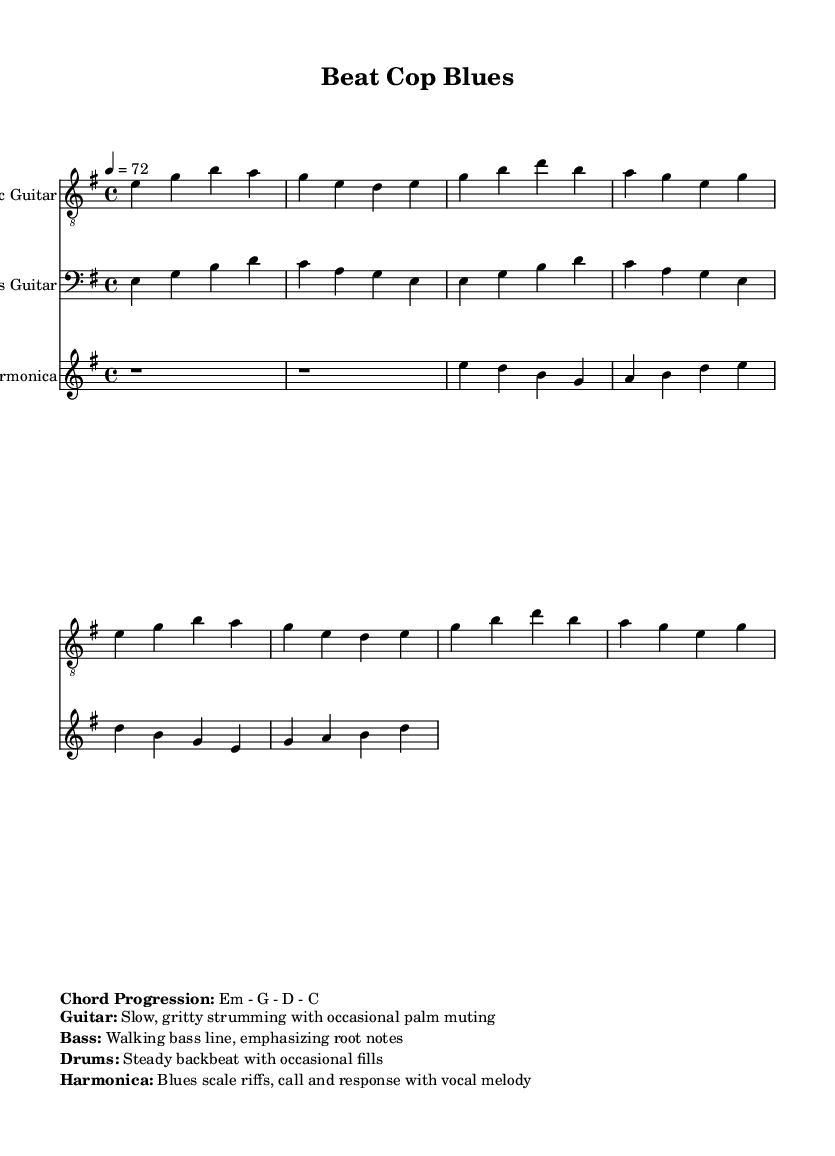What is the time signature of the music? The time signature is indicated at the beginning of the piece as a fraction, showing the number of beats per measure. In this case, it is shown as 4/4.
Answer: 4/4 What key is this piece written in? The key signature is found at the beginning of the score. It shows the piece is in E minor, as indicated by the key signature symbol.
Answer: E minor What is the tempo marking specified in the music? The tempo marking indicates the speed of the piece, typically noted in beats per minute. Here, it is written as "4 = 72."
Answer: 72 How many measures are repeated in the electric guitar part? The electric guitar part contains a section that uses the "repeat" directive, suggesting it should be played two times.
Answer: 2 Which instrument plays the walking bass line? The bass guitar section, designated in the score, typically performs a walking bass line which emphasizes the root notes. This information is explicitly described in the musical directions.
Answer: Bass Guitar What style of strumming is indicated for the electric guitar? The instructions state the guitar uses "slow, gritty strumming with occasional palm muting," indicating the technique to be used throughout the piece.
Answer: Slow, gritty strumming Which instrument features blues scale riffs? The harmonica section is described as playing blues scale riffs, especially with a call and response approach to the vocal melody based on its marked characteristics.
Answer: Harmonica 